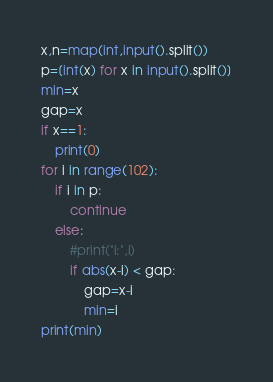<code> <loc_0><loc_0><loc_500><loc_500><_Python_>x,n=map(int,input().split())
p=[int(x) for x in input().split()]
min=x
gap=x
if x==1:
	print(0)
for i in range(102):
	if i in p:
		continue
	else:
		#print("i:",i)
		if abs(x-i) < gap:
			gap=x-i
			min=i
print(min)</code> 